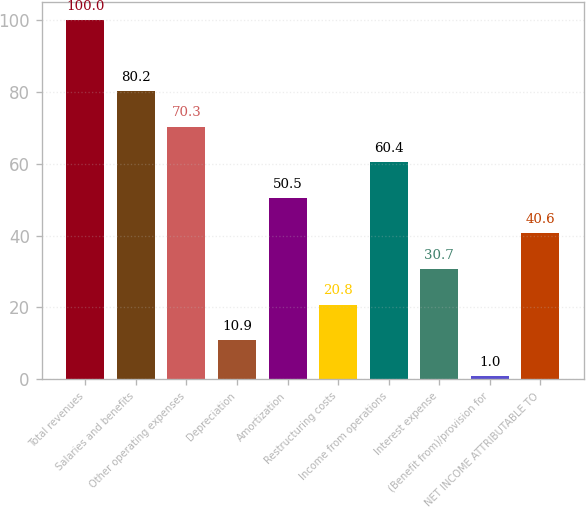<chart> <loc_0><loc_0><loc_500><loc_500><bar_chart><fcel>Total revenues<fcel>Salaries and benefits<fcel>Other operating expenses<fcel>Depreciation<fcel>Amortization<fcel>Restructuring costs<fcel>Income from operations<fcel>Interest expense<fcel>(Benefit from)/provision for<fcel>NET INCOME ATTRIBUTABLE TO<nl><fcel>100<fcel>80.2<fcel>70.3<fcel>10.9<fcel>50.5<fcel>20.8<fcel>60.4<fcel>30.7<fcel>1<fcel>40.6<nl></chart> 